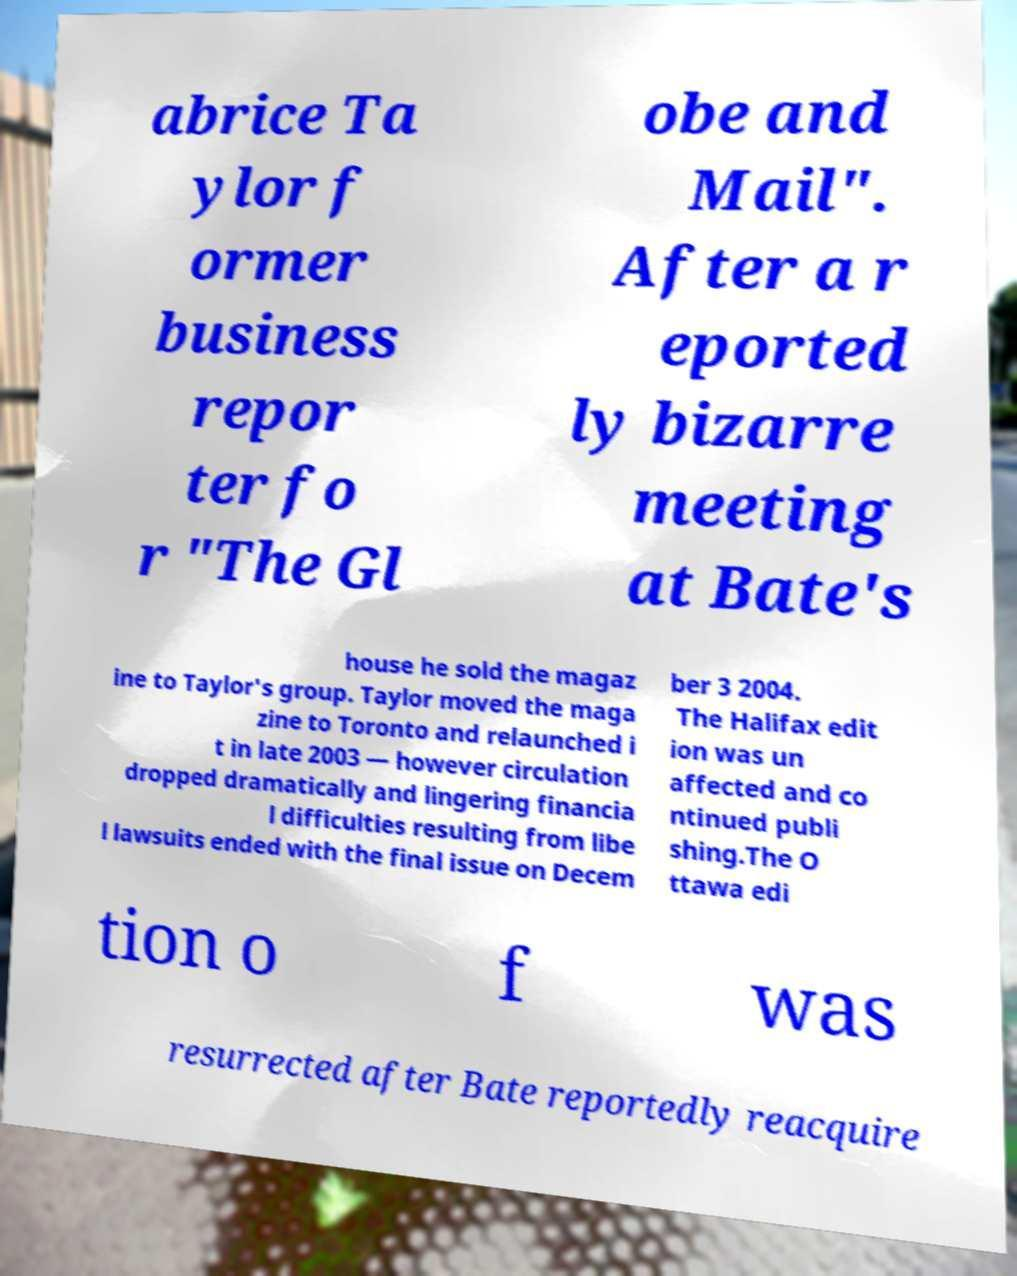I need the written content from this picture converted into text. Can you do that? abrice Ta ylor f ormer business repor ter fo r "The Gl obe and Mail". After a r eported ly bizarre meeting at Bate's house he sold the magaz ine to Taylor's group. Taylor moved the maga zine to Toronto and relaunched i t in late 2003 — however circulation dropped dramatically and lingering financia l difficulties resulting from libe l lawsuits ended with the final issue on Decem ber 3 2004. The Halifax edit ion was un affected and co ntinued publi shing.The O ttawa edi tion o f was resurrected after Bate reportedly reacquire 